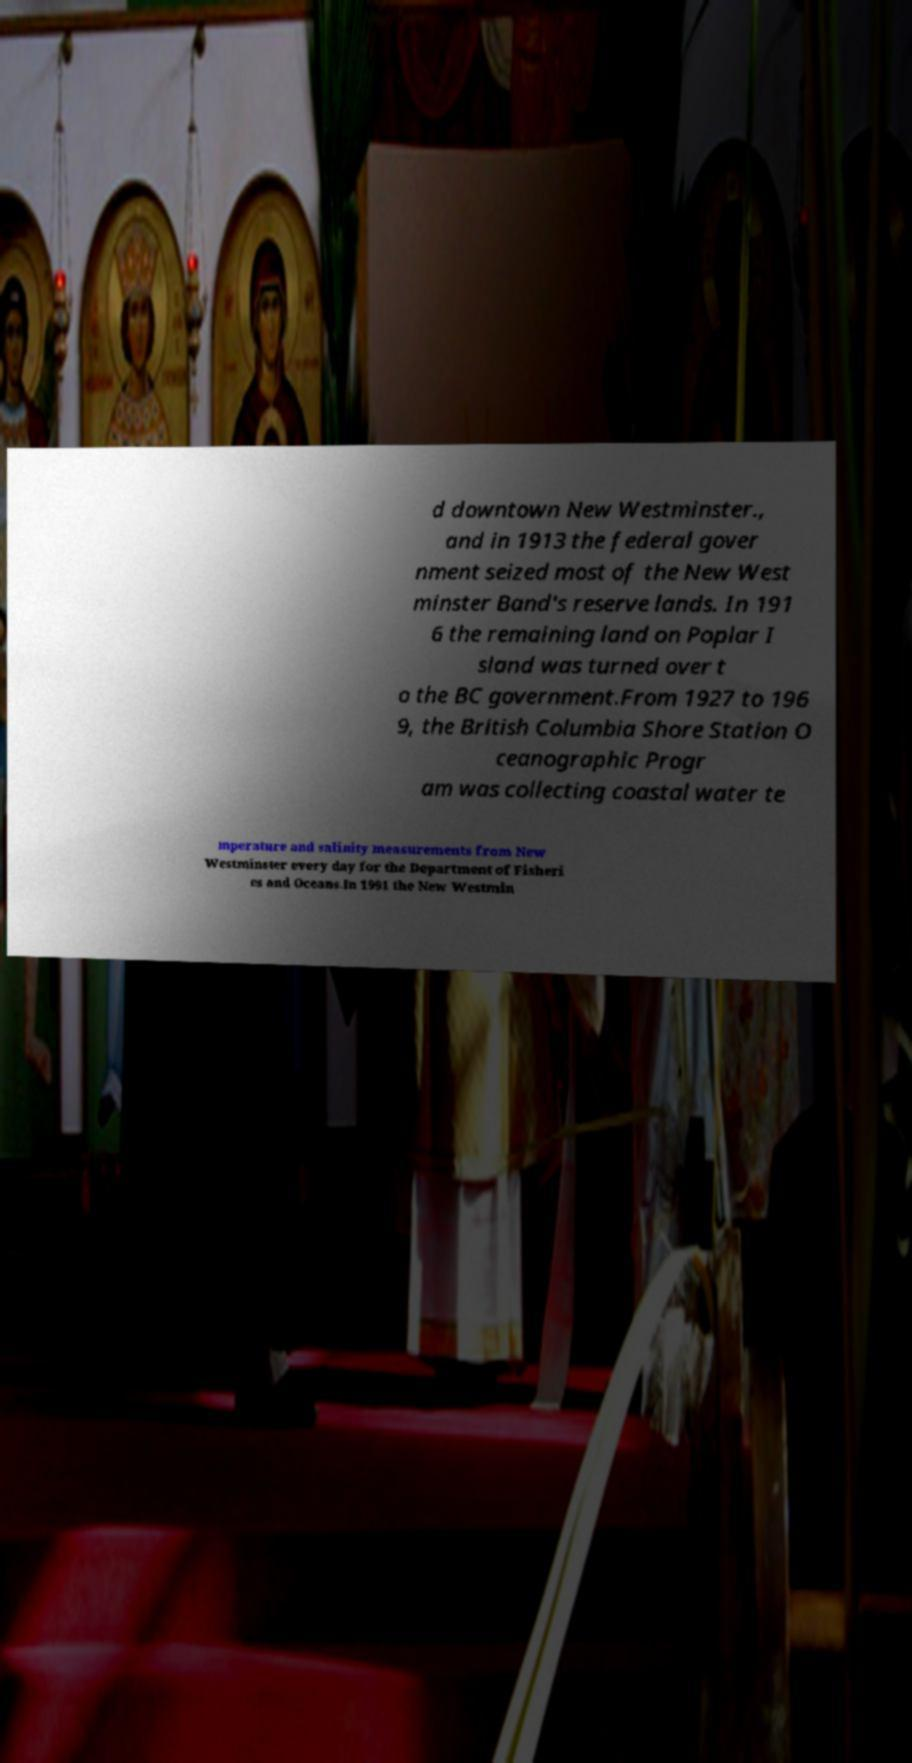There's text embedded in this image that I need extracted. Can you transcribe it verbatim? d downtown New Westminster., and in 1913 the federal gover nment seized most of the New West minster Band's reserve lands. In 191 6 the remaining land on Poplar I sland was turned over t o the BC government.From 1927 to 196 9, the British Columbia Shore Station O ceanographic Progr am was collecting coastal water te mperature and salinity measurements from New Westminster every day for the Department of Fisheri es and Oceans.In 1991 the New Westmin 